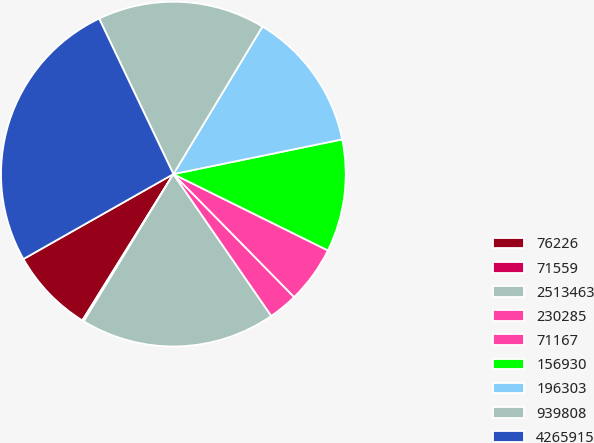Convert chart to OTSL. <chart><loc_0><loc_0><loc_500><loc_500><pie_chart><fcel>76226<fcel>71559<fcel>2513463<fcel>230285<fcel>71167<fcel>156930<fcel>196303<fcel>939808<fcel>4265915<nl><fcel>7.94%<fcel>0.15%<fcel>18.32%<fcel>2.74%<fcel>5.34%<fcel>10.53%<fcel>13.13%<fcel>15.73%<fcel>26.11%<nl></chart> 